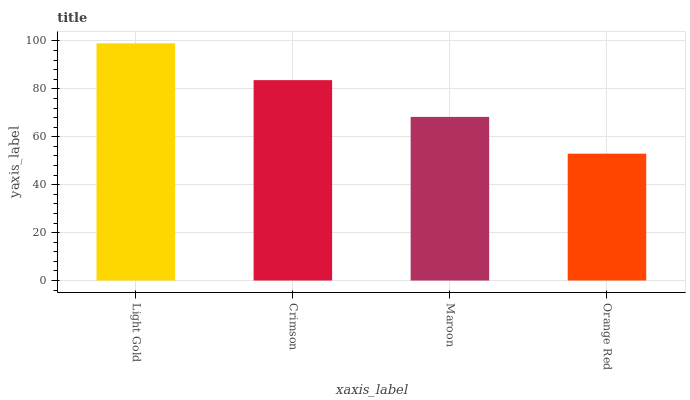Is Orange Red the minimum?
Answer yes or no. Yes. Is Light Gold the maximum?
Answer yes or no. Yes. Is Crimson the minimum?
Answer yes or no. No. Is Crimson the maximum?
Answer yes or no. No. Is Light Gold greater than Crimson?
Answer yes or no. Yes. Is Crimson less than Light Gold?
Answer yes or no. Yes. Is Crimson greater than Light Gold?
Answer yes or no. No. Is Light Gold less than Crimson?
Answer yes or no. No. Is Crimson the high median?
Answer yes or no. Yes. Is Maroon the low median?
Answer yes or no. Yes. Is Maroon the high median?
Answer yes or no. No. Is Crimson the low median?
Answer yes or no. No. 